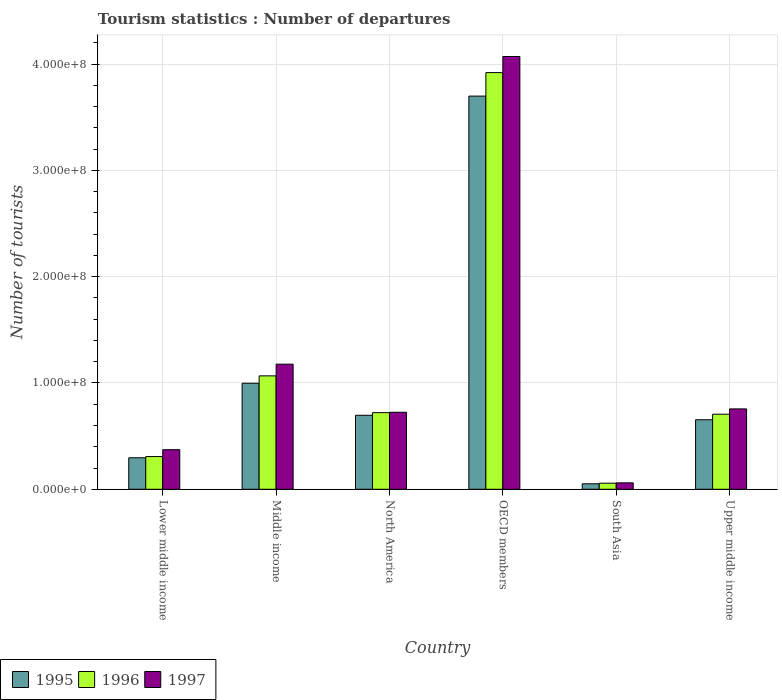Are the number of bars per tick equal to the number of legend labels?
Keep it short and to the point. Yes. What is the label of the 6th group of bars from the left?
Your response must be concise. Upper middle income. What is the number of tourist departures in 1996 in North America?
Offer a very short reply. 7.21e+07. Across all countries, what is the maximum number of tourist departures in 1995?
Keep it short and to the point. 3.70e+08. Across all countries, what is the minimum number of tourist departures in 1995?
Offer a terse response. 5.17e+06. In which country was the number of tourist departures in 1996 maximum?
Give a very brief answer. OECD members. What is the total number of tourist departures in 1997 in the graph?
Give a very brief answer. 7.16e+08. What is the difference between the number of tourist departures in 1996 in Lower middle income and that in Upper middle income?
Keep it short and to the point. -3.99e+07. What is the difference between the number of tourist departures in 1995 in North America and the number of tourist departures in 1997 in OECD members?
Provide a succinct answer. -3.38e+08. What is the average number of tourist departures in 1996 per country?
Give a very brief answer. 1.13e+08. What is the difference between the number of tourist departures of/in 1996 and number of tourist departures of/in 1995 in Lower middle income?
Ensure brevity in your answer.  1.14e+06. In how many countries, is the number of tourist departures in 1997 greater than 360000000?
Keep it short and to the point. 1. What is the ratio of the number of tourist departures in 1996 in Lower middle income to that in Middle income?
Offer a very short reply. 0.29. What is the difference between the highest and the second highest number of tourist departures in 1997?
Keep it short and to the point. 4.21e+07. What is the difference between the highest and the lowest number of tourist departures in 1997?
Offer a very short reply. 4.01e+08. Is the sum of the number of tourist departures in 1997 in Lower middle income and South Asia greater than the maximum number of tourist departures in 1995 across all countries?
Keep it short and to the point. No. How many bars are there?
Your answer should be compact. 18. Are all the bars in the graph horizontal?
Keep it short and to the point. No. Does the graph contain grids?
Your answer should be very brief. Yes. How many legend labels are there?
Offer a terse response. 3. What is the title of the graph?
Provide a succinct answer. Tourism statistics : Number of departures. What is the label or title of the Y-axis?
Keep it short and to the point. Number of tourists. What is the Number of tourists in 1995 in Lower middle income?
Offer a very short reply. 2.96e+07. What is the Number of tourists of 1996 in Lower middle income?
Make the answer very short. 3.08e+07. What is the Number of tourists of 1997 in Lower middle income?
Provide a short and direct response. 3.73e+07. What is the Number of tourists of 1995 in Middle income?
Your answer should be very brief. 9.98e+07. What is the Number of tourists of 1996 in Middle income?
Offer a very short reply. 1.07e+08. What is the Number of tourists in 1997 in Middle income?
Ensure brevity in your answer.  1.18e+08. What is the Number of tourists of 1995 in North America?
Keep it short and to the point. 6.96e+07. What is the Number of tourists in 1996 in North America?
Your response must be concise. 7.21e+07. What is the Number of tourists of 1997 in North America?
Make the answer very short. 7.25e+07. What is the Number of tourists of 1995 in OECD members?
Your response must be concise. 3.70e+08. What is the Number of tourists in 1996 in OECD members?
Provide a succinct answer. 3.92e+08. What is the Number of tourists of 1997 in OECD members?
Your answer should be compact. 4.07e+08. What is the Number of tourists in 1995 in South Asia?
Make the answer very short. 5.17e+06. What is the Number of tourists of 1996 in South Asia?
Your answer should be very brief. 5.74e+06. What is the Number of tourists in 1997 in South Asia?
Provide a succinct answer. 6.04e+06. What is the Number of tourists in 1995 in Upper middle income?
Provide a short and direct response. 6.54e+07. What is the Number of tourists in 1996 in Upper middle income?
Offer a terse response. 7.06e+07. What is the Number of tourists in 1997 in Upper middle income?
Offer a very short reply. 7.56e+07. Across all countries, what is the maximum Number of tourists in 1995?
Keep it short and to the point. 3.70e+08. Across all countries, what is the maximum Number of tourists of 1996?
Give a very brief answer. 3.92e+08. Across all countries, what is the maximum Number of tourists in 1997?
Keep it short and to the point. 4.07e+08. Across all countries, what is the minimum Number of tourists of 1995?
Offer a terse response. 5.17e+06. Across all countries, what is the minimum Number of tourists of 1996?
Offer a very short reply. 5.74e+06. Across all countries, what is the minimum Number of tourists of 1997?
Offer a terse response. 6.04e+06. What is the total Number of tourists in 1995 in the graph?
Your response must be concise. 6.40e+08. What is the total Number of tourists of 1996 in the graph?
Give a very brief answer. 6.78e+08. What is the total Number of tourists in 1997 in the graph?
Your answer should be very brief. 7.16e+08. What is the difference between the Number of tourists in 1995 in Lower middle income and that in Middle income?
Your response must be concise. -7.01e+07. What is the difference between the Number of tourists of 1996 in Lower middle income and that in Middle income?
Give a very brief answer. -7.59e+07. What is the difference between the Number of tourists of 1997 in Lower middle income and that in Middle income?
Provide a short and direct response. -8.04e+07. What is the difference between the Number of tourists of 1995 in Lower middle income and that in North America?
Your answer should be very brief. -4.00e+07. What is the difference between the Number of tourists in 1996 in Lower middle income and that in North America?
Ensure brevity in your answer.  -4.13e+07. What is the difference between the Number of tourists in 1997 in Lower middle income and that in North America?
Your response must be concise. -3.52e+07. What is the difference between the Number of tourists of 1995 in Lower middle income and that in OECD members?
Your answer should be very brief. -3.40e+08. What is the difference between the Number of tourists in 1996 in Lower middle income and that in OECD members?
Your answer should be compact. -3.61e+08. What is the difference between the Number of tourists in 1997 in Lower middle income and that in OECD members?
Offer a very short reply. -3.70e+08. What is the difference between the Number of tourists in 1995 in Lower middle income and that in South Asia?
Your answer should be compact. 2.45e+07. What is the difference between the Number of tourists in 1996 in Lower middle income and that in South Asia?
Make the answer very short. 2.50e+07. What is the difference between the Number of tourists of 1997 in Lower middle income and that in South Asia?
Make the answer very short. 3.12e+07. What is the difference between the Number of tourists in 1995 in Lower middle income and that in Upper middle income?
Your response must be concise. -3.58e+07. What is the difference between the Number of tourists in 1996 in Lower middle income and that in Upper middle income?
Keep it short and to the point. -3.99e+07. What is the difference between the Number of tourists of 1997 in Lower middle income and that in Upper middle income?
Your answer should be compact. -3.84e+07. What is the difference between the Number of tourists of 1995 in Middle income and that in North America?
Ensure brevity in your answer.  3.02e+07. What is the difference between the Number of tourists in 1996 in Middle income and that in North America?
Your answer should be compact. 3.46e+07. What is the difference between the Number of tourists in 1997 in Middle income and that in North America?
Your answer should be very brief. 4.52e+07. What is the difference between the Number of tourists in 1995 in Middle income and that in OECD members?
Your answer should be compact. -2.70e+08. What is the difference between the Number of tourists in 1996 in Middle income and that in OECD members?
Your answer should be very brief. -2.85e+08. What is the difference between the Number of tourists in 1997 in Middle income and that in OECD members?
Your response must be concise. -2.89e+08. What is the difference between the Number of tourists in 1995 in Middle income and that in South Asia?
Offer a terse response. 9.46e+07. What is the difference between the Number of tourists of 1996 in Middle income and that in South Asia?
Your answer should be very brief. 1.01e+08. What is the difference between the Number of tourists of 1997 in Middle income and that in South Asia?
Keep it short and to the point. 1.12e+08. What is the difference between the Number of tourists of 1995 in Middle income and that in Upper middle income?
Your response must be concise. 3.43e+07. What is the difference between the Number of tourists of 1996 in Middle income and that in Upper middle income?
Your response must be concise. 3.61e+07. What is the difference between the Number of tourists in 1997 in Middle income and that in Upper middle income?
Your answer should be compact. 4.21e+07. What is the difference between the Number of tourists in 1995 in North America and that in OECD members?
Provide a short and direct response. -3.00e+08. What is the difference between the Number of tourists of 1996 in North America and that in OECD members?
Your answer should be compact. -3.20e+08. What is the difference between the Number of tourists of 1997 in North America and that in OECD members?
Offer a terse response. -3.35e+08. What is the difference between the Number of tourists in 1995 in North America and that in South Asia?
Offer a terse response. 6.44e+07. What is the difference between the Number of tourists in 1996 in North America and that in South Asia?
Your response must be concise. 6.64e+07. What is the difference between the Number of tourists of 1997 in North America and that in South Asia?
Offer a terse response. 6.64e+07. What is the difference between the Number of tourists in 1995 in North America and that in Upper middle income?
Make the answer very short. 4.19e+06. What is the difference between the Number of tourists in 1996 in North America and that in Upper middle income?
Make the answer very short. 1.47e+06. What is the difference between the Number of tourists in 1997 in North America and that in Upper middle income?
Your response must be concise. -3.15e+06. What is the difference between the Number of tourists of 1995 in OECD members and that in South Asia?
Ensure brevity in your answer.  3.65e+08. What is the difference between the Number of tourists of 1996 in OECD members and that in South Asia?
Your answer should be compact. 3.86e+08. What is the difference between the Number of tourists of 1997 in OECD members and that in South Asia?
Keep it short and to the point. 4.01e+08. What is the difference between the Number of tourists in 1995 in OECD members and that in Upper middle income?
Give a very brief answer. 3.05e+08. What is the difference between the Number of tourists of 1996 in OECD members and that in Upper middle income?
Ensure brevity in your answer.  3.21e+08. What is the difference between the Number of tourists in 1997 in OECD members and that in Upper middle income?
Offer a terse response. 3.32e+08. What is the difference between the Number of tourists of 1995 in South Asia and that in Upper middle income?
Provide a succinct answer. -6.03e+07. What is the difference between the Number of tourists in 1996 in South Asia and that in Upper middle income?
Ensure brevity in your answer.  -6.49e+07. What is the difference between the Number of tourists in 1997 in South Asia and that in Upper middle income?
Provide a short and direct response. -6.96e+07. What is the difference between the Number of tourists of 1995 in Lower middle income and the Number of tourists of 1996 in Middle income?
Your answer should be very brief. -7.71e+07. What is the difference between the Number of tourists in 1995 in Lower middle income and the Number of tourists in 1997 in Middle income?
Ensure brevity in your answer.  -8.81e+07. What is the difference between the Number of tourists of 1996 in Lower middle income and the Number of tourists of 1997 in Middle income?
Provide a succinct answer. -8.69e+07. What is the difference between the Number of tourists of 1995 in Lower middle income and the Number of tourists of 1996 in North America?
Ensure brevity in your answer.  -4.25e+07. What is the difference between the Number of tourists of 1995 in Lower middle income and the Number of tourists of 1997 in North America?
Provide a short and direct response. -4.28e+07. What is the difference between the Number of tourists of 1996 in Lower middle income and the Number of tourists of 1997 in North America?
Ensure brevity in your answer.  -4.17e+07. What is the difference between the Number of tourists in 1995 in Lower middle income and the Number of tourists in 1996 in OECD members?
Offer a terse response. -3.62e+08. What is the difference between the Number of tourists of 1995 in Lower middle income and the Number of tourists of 1997 in OECD members?
Offer a terse response. -3.78e+08. What is the difference between the Number of tourists of 1996 in Lower middle income and the Number of tourists of 1997 in OECD members?
Your answer should be compact. -3.76e+08. What is the difference between the Number of tourists in 1995 in Lower middle income and the Number of tourists in 1996 in South Asia?
Offer a very short reply. 2.39e+07. What is the difference between the Number of tourists in 1995 in Lower middle income and the Number of tourists in 1997 in South Asia?
Your answer should be compact. 2.36e+07. What is the difference between the Number of tourists in 1996 in Lower middle income and the Number of tourists in 1997 in South Asia?
Offer a very short reply. 2.47e+07. What is the difference between the Number of tourists of 1995 in Lower middle income and the Number of tourists of 1996 in Upper middle income?
Give a very brief answer. -4.10e+07. What is the difference between the Number of tourists in 1995 in Lower middle income and the Number of tourists in 1997 in Upper middle income?
Offer a terse response. -4.60e+07. What is the difference between the Number of tourists of 1996 in Lower middle income and the Number of tourists of 1997 in Upper middle income?
Give a very brief answer. -4.48e+07. What is the difference between the Number of tourists in 1995 in Middle income and the Number of tourists in 1996 in North America?
Provide a short and direct response. 2.77e+07. What is the difference between the Number of tourists of 1995 in Middle income and the Number of tourists of 1997 in North America?
Keep it short and to the point. 2.73e+07. What is the difference between the Number of tourists of 1996 in Middle income and the Number of tourists of 1997 in North America?
Offer a very short reply. 3.42e+07. What is the difference between the Number of tourists in 1995 in Middle income and the Number of tourists in 1996 in OECD members?
Give a very brief answer. -2.92e+08. What is the difference between the Number of tourists of 1995 in Middle income and the Number of tourists of 1997 in OECD members?
Provide a short and direct response. -3.07e+08. What is the difference between the Number of tourists in 1996 in Middle income and the Number of tourists in 1997 in OECD members?
Provide a short and direct response. -3.00e+08. What is the difference between the Number of tourists in 1995 in Middle income and the Number of tourists in 1996 in South Asia?
Provide a short and direct response. 9.40e+07. What is the difference between the Number of tourists of 1995 in Middle income and the Number of tourists of 1997 in South Asia?
Ensure brevity in your answer.  9.37e+07. What is the difference between the Number of tourists of 1996 in Middle income and the Number of tourists of 1997 in South Asia?
Provide a short and direct response. 1.01e+08. What is the difference between the Number of tourists of 1995 in Middle income and the Number of tourists of 1996 in Upper middle income?
Provide a succinct answer. 2.91e+07. What is the difference between the Number of tourists in 1995 in Middle income and the Number of tourists in 1997 in Upper middle income?
Ensure brevity in your answer.  2.41e+07. What is the difference between the Number of tourists of 1996 in Middle income and the Number of tourists of 1997 in Upper middle income?
Ensure brevity in your answer.  3.11e+07. What is the difference between the Number of tourists in 1995 in North America and the Number of tourists in 1996 in OECD members?
Your answer should be compact. -3.22e+08. What is the difference between the Number of tourists in 1995 in North America and the Number of tourists in 1997 in OECD members?
Give a very brief answer. -3.38e+08. What is the difference between the Number of tourists in 1996 in North America and the Number of tourists in 1997 in OECD members?
Your answer should be compact. -3.35e+08. What is the difference between the Number of tourists in 1995 in North America and the Number of tourists in 1996 in South Asia?
Your response must be concise. 6.39e+07. What is the difference between the Number of tourists in 1995 in North America and the Number of tourists in 1997 in South Asia?
Keep it short and to the point. 6.36e+07. What is the difference between the Number of tourists of 1996 in North America and the Number of tourists of 1997 in South Asia?
Offer a very short reply. 6.61e+07. What is the difference between the Number of tourists in 1995 in North America and the Number of tourists in 1996 in Upper middle income?
Give a very brief answer. -1.02e+06. What is the difference between the Number of tourists of 1995 in North America and the Number of tourists of 1997 in Upper middle income?
Offer a terse response. -6.01e+06. What is the difference between the Number of tourists of 1996 in North America and the Number of tourists of 1997 in Upper middle income?
Ensure brevity in your answer.  -3.52e+06. What is the difference between the Number of tourists of 1995 in OECD members and the Number of tourists of 1996 in South Asia?
Offer a very short reply. 3.64e+08. What is the difference between the Number of tourists of 1995 in OECD members and the Number of tourists of 1997 in South Asia?
Ensure brevity in your answer.  3.64e+08. What is the difference between the Number of tourists of 1996 in OECD members and the Number of tourists of 1997 in South Asia?
Keep it short and to the point. 3.86e+08. What is the difference between the Number of tourists of 1995 in OECD members and the Number of tourists of 1996 in Upper middle income?
Your answer should be compact. 2.99e+08. What is the difference between the Number of tourists in 1995 in OECD members and the Number of tourists in 1997 in Upper middle income?
Offer a very short reply. 2.94e+08. What is the difference between the Number of tourists of 1996 in OECD members and the Number of tourists of 1997 in Upper middle income?
Provide a succinct answer. 3.16e+08. What is the difference between the Number of tourists of 1995 in South Asia and the Number of tourists of 1996 in Upper middle income?
Ensure brevity in your answer.  -6.55e+07. What is the difference between the Number of tourists in 1995 in South Asia and the Number of tourists in 1997 in Upper middle income?
Offer a very short reply. -7.05e+07. What is the difference between the Number of tourists of 1996 in South Asia and the Number of tourists of 1997 in Upper middle income?
Your answer should be very brief. -6.99e+07. What is the average Number of tourists in 1995 per country?
Your answer should be compact. 1.07e+08. What is the average Number of tourists in 1996 per country?
Ensure brevity in your answer.  1.13e+08. What is the average Number of tourists in 1997 per country?
Your response must be concise. 1.19e+08. What is the difference between the Number of tourists of 1995 and Number of tourists of 1996 in Lower middle income?
Ensure brevity in your answer.  -1.14e+06. What is the difference between the Number of tourists in 1995 and Number of tourists in 1997 in Lower middle income?
Provide a succinct answer. -7.61e+06. What is the difference between the Number of tourists in 1996 and Number of tourists in 1997 in Lower middle income?
Ensure brevity in your answer.  -6.47e+06. What is the difference between the Number of tourists in 1995 and Number of tourists in 1996 in Middle income?
Give a very brief answer. -6.94e+06. What is the difference between the Number of tourists in 1995 and Number of tourists in 1997 in Middle income?
Make the answer very short. -1.79e+07. What is the difference between the Number of tourists of 1996 and Number of tourists of 1997 in Middle income?
Ensure brevity in your answer.  -1.10e+07. What is the difference between the Number of tourists of 1995 and Number of tourists of 1996 in North America?
Make the answer very short. -2.49e+06. What is the difference between the Number of tourists of 1995 and Number of tourists of 1997 in North America?
Give a very brief answer. -2.85e+06. What is the difference between the Number of tourists of 1996 and Number of tourists of 1997 in North America?
Make the answer very short. -3.69e+05. What is the difference between the Number of tourists of 1995 and Number of tourists of 1996 in OECD members?
Keep it short and to the point. -2.21e+07. What is the difference between the Number of tourists in 1995 and Number of tourists in 1997 in OECD members?
Your response must be concise. -3.72e+07. What is the difference between the Number of tourists of 1996 and Number of tourists of 1997 in OECD members?
Give a very brief answer. -1.51e+07. What is the difference between the Number of tourists of 1995 and Number of tourists of 1996 in South Asia?
Provide a succinct answer. -5.69e+05. What is the difference between the Number of tourists in 1995 and Number of tourists in 1997 in South Asia?
Give a very brief answer. -8.75e+05. What is the difference between the Number of tourists in 1996 and Number of tourists in 1997 in South Asia?
Your answer should be compact. -3.06e+05. What is the difference between the Number of tourists of 1995 and Number of tourists of 1996 in Upper middle income?
Your answer should be very brief. -5.21e+06. What is the difference between the Number of tourists in 1995 and Number of tourists in 1997 in Upper middle income?
Your answer should be compact. -1.02e+07. What is the difference between the Number of tourists in 1996 and Number of tourists in 1997 in Upper middle income?
Keep it short and to the point. -4.99e+06. What is the ratio of the Number of tourists in 1995 in Lower middle income to that in Middle income?
Provide a short and direct response. 0.3. What is the ratio of the Number of tourists of 1996 in Lower middle income to that in Middle income?
Offer a terse response. 0.29. What is the ratio of the Number of tourists of 1997 in Lower middle income to that in Middle income?
Keep it short and to the point. 0.32. What is the ratio of the Number of tourists of 1995 in Lower middle income to that in North America?
Keep it short and to the point. 0.43. What is the ratio of the Number of tourists in 1996 in Lower middle income to that in North America?
Provide a succinct answer. 0.43. What is the ratio of the Number of tourists in 1997 in Lower middle income to that in North America?
Offer a terse response. 0.51. What is the ratio of the Number of tourists in 1995 in Lower middle income to that in OECD members?
Keep it short and to the point. 0.08. What is the ratio of the Number of tourists in 1996 in Lower middle income to that in OECD members?
Give a very brief answer. 0.08. What is the ratio of the Number of tourists in 1997 in Lower middle income to that in OECD members?
Provide a short and direct response. 0.09. What is the ratio of the Number of tourists of 1995 in Lower middle income to that in South Asia?
Offer a terse response. 5.74. What is the ratio of the Number of tourists in 1996 in Lower middle income to that in South Asia?
Make the answer very short. 5.37. What is the ratio of the Number of tourists in 1997 in Lower middle income to that in South Asia?
Provide a succinct answer. 6.17. What is the ratio of the Number of tourists in 1995 in Lower middle income to that in Upper middle income?
Provide a succinct answer. 0.45. What is the ratio of the Number of tourists in 1996 in Lower middle income to that in Upper middle income?
Offer a very short reply. 0.44. What is the ratio of the Number of tourists of 1997 in Lower middle income to that in Upper middle income?
Your answer should be very brief. 0.49. What is the ratio of the Number of tourists in 1995 in Middle income to that in North America?
Give a very brief answer. 1.43. What is the ratio of the Number of tourists in 1996 in Middle income to that in North America?
Keep it short and to the point. 1.48. What is the ratio of the Number of tourists in 1997 in Middle income to that in North America?
Make the answer very short. 1.62. What is the ratio of the Number of tourists in 1995 in Middle income to that in OECD members?
Provide a succinct answer. 0.27. What is the ratio of the Number of tourists of 1996 in Middle income to that in OECD members?
Keep it short and to the point. 0.27. What is the ratio of the Number of tourists in 1997 in Middle income to that in OECD members?
Provide a succinct answer. 0.29. What is the ratio of the Number of tourists in 1995 in Middle income to that in South Asia?
Offer a terse response. 19.31. What is the ratio of the Number of tourists of 1996 in Middle income to that in South Asia?
Your answer should be compact. 18.61. What is the ratio of the Number of tourists of 1997 in Middle income to that in South Asia?
Give a very brief answer. 19.48. What is the ratio of the Number of tourists of 1995 in Middle income to that in Upper middle income?
Provide a short and direct response. 1.52. What is the ratio of the Number of tourists in 1996 in Middle income to that in Upper middle income?
Your answer should be very brief. 1.51. What is the ratio of the Number of tourists in 1997 in Middle income to that in Upper middle income?
Keep it short and to the point. 1.56. What is the ratio of the Number of tourists in 1995 in North America to that in OECD members?
Offer a very short reply. 0.19. What is the ratio of the Number of tourists of 1996 in North America to that in OECD members?
Keep it short and to the point. 0.18. What is the ratio of the Number of tourists in 1997 in North America to that in OECD members?
Give a very brief answer. 0.18. What is the ratio of the Number of tourists of 1995 in North America to that in South Asia?
Make the answer very short. 13.47. What is the ratio of the Number of tourists of 1996 in North America to that in South Asia?
Provide a succinct answer. 12.57. What is the ratio of the Number of tourists in 1997 in North America to that in South Asia?
Provide a succinct answer. 12. What is the ratio of the Number of tourists in 1995 in North America to that in Upper middle income?
Give a very brief answer. 1.06. What is the ratio of the Number of tourists of 1996 in North America to that in Upper middle income?
Provide a succinct answer. 1.02. What is the ratio of the Number of tourists of 1997 in North America to that in Upper middle income?
Offer a very short reply. 0.96. What is the ratio of the Number of tourists in 1995 in OECD members to that in South Asia?
Make the answer very short. 71.61. What is the ratio of the Number of tourists in 1996 in OECD members to that in South Asia?
Provide a succinct answer. 68.36. What is the ratio of the Number of tourists of 1997 in OECD members to that in South Asia?
Keep it short and to the point. 67.4. What is the ratio of the Number of tourists of 1995 in OECD members to that in Upper middle income?
Offer a terse response. 5.65. What is the ratio of the Number of tourists in 1996 in OECD members to that in Upper middle income?
Provide a short and direct response. 5.55. What is the ratio of the Number of tourists of 1997 in OECD members to that in Upper middle income?
Offer a very short reply. 5.38. What is the ratio of the Number of tourists of 1995 in South Asia to that in Upper middle income?
Ensure brevity in your answer.  0.08. What is the ratio of the Number of tourists of 1996 in South Asia to that in Upper middle income?
Keep it short and to the point. 0.08. What is the ratio of the Number of tourists in 1997 in South Asia to that in Upper middle income?
Your answer should be very brief. 0.08. What is the difference between the highest and the second highest Number of tourists of 1995?
Keep it short and to the point. 2.70e+08. What is the difference between the highest and the second highest Number of tourists of 1996?
Offer a very short reply. 2.85e+08. What is the difference between the highest and the second highest Number of tourists in 1997?
Your response must be concise. 2.89e+08. What is the difference between the highest and the lowest Number of tourists in 1995?
Offer a terse response. 3.65e+08. What is the difference between the highest and the lowest Number of tourists in 1996?
Your answer should be very brief. 3.86e+08. What is the difference between the highest and the lowest Number of tourists in 1997?
Offer a very short reply. 4.01e+08. 